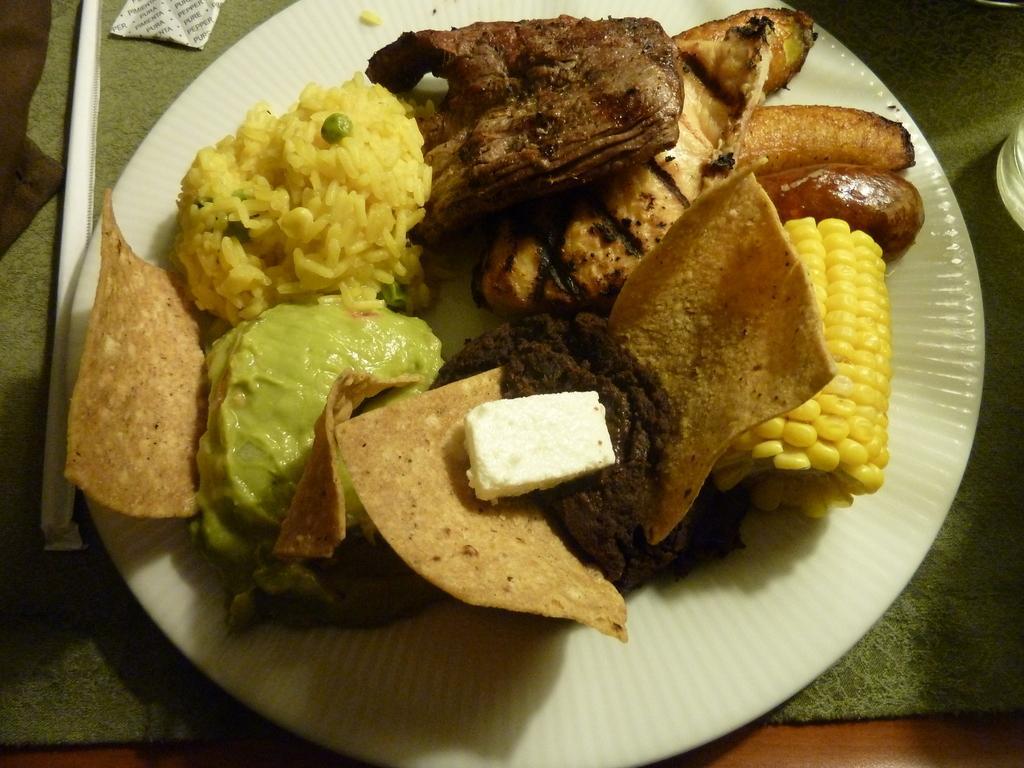Can you describe this image briefly? In this picture we can see food items in the plate and this plate is on the platform. 